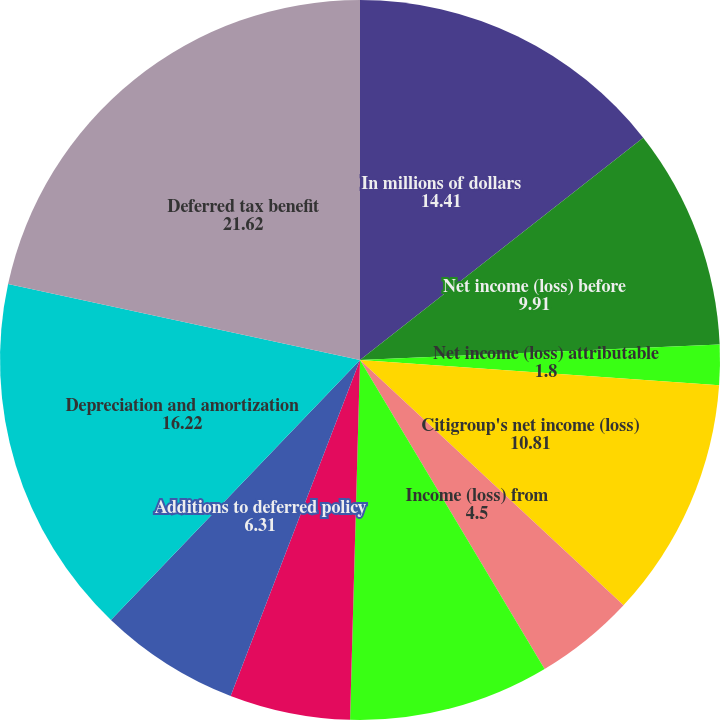<chart> <loc_0><loc_0><loc_500><loc_500><pie_chart><fcel>In millions of dollars<fcel>Net income (loss) before<fcel>Net income (loss) attributable<fcel>Citigroup's net income (loss)<fcel>Income (loss) from<fcel>Income (loss) from continuing<fcel>Amortization of deferred<fcel>Additions to deferred policy<fcel>Depreciation and amortization<fcel>Deferred tax benefit<nl><fcel>14.41%<fcel>9.91%<fcel>1.8%<fcel>10.81%<fcel>4.5%<fcel>9.01%<fcel>5.41%<fcel>6.31%<fcel>16.22%<fcel>21.62%<nl></chart> 